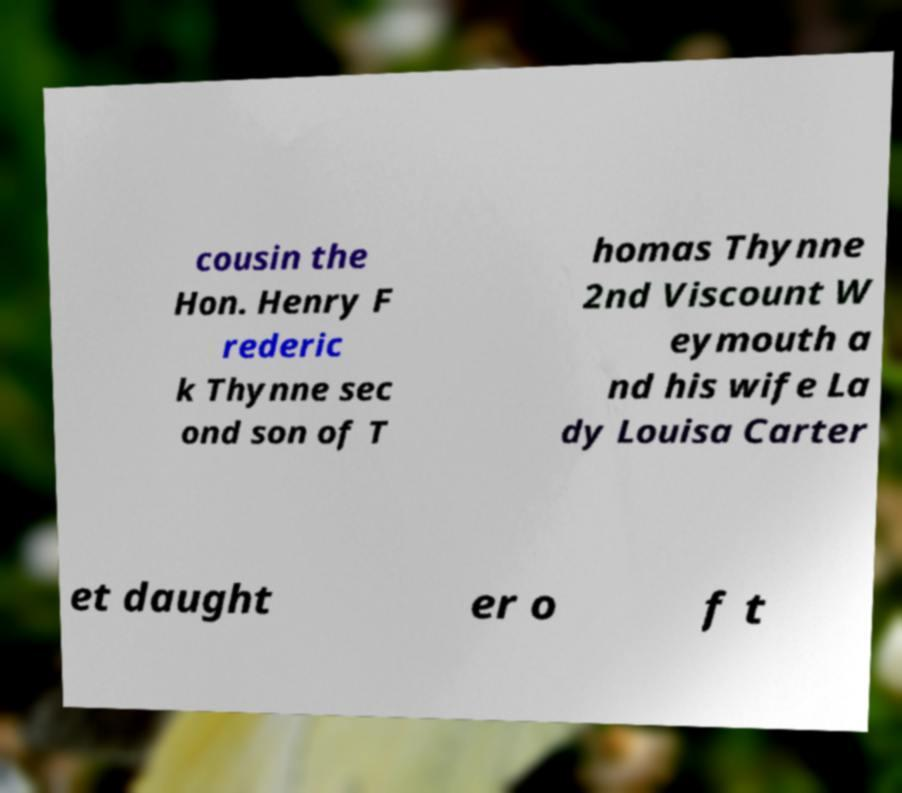Please read and relay the text visible in this image. What does it say? cousin the Hon. Henry F rederic k Thynne sec ond son of T homas Thynne 2nd Viscount W eymouth a nd his wife La dy Louisa Carter et daught er o f t 